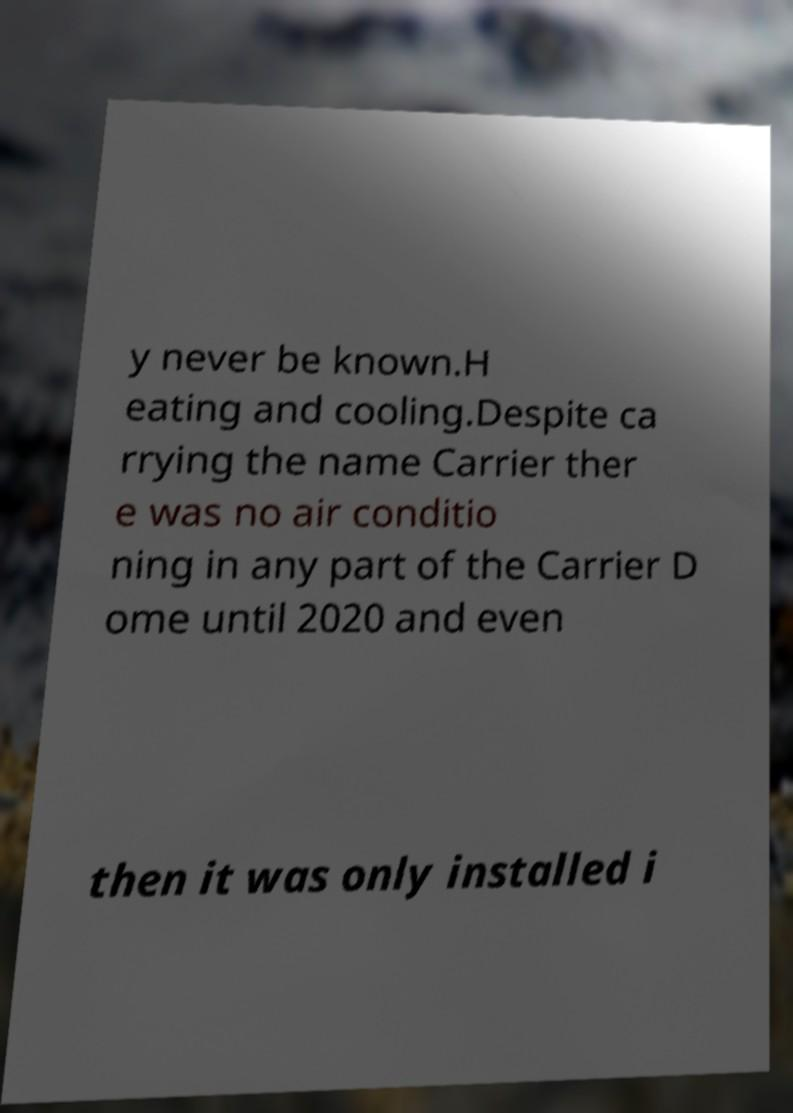Could you assist in decoding the text presented in this image and type it out clearly? y never be known.H eating and cooling.Despite ca rrying the name Carrier ther e was no air conditio ning in any part of the Carrier D ome until 2020 and even then it was only installed i 